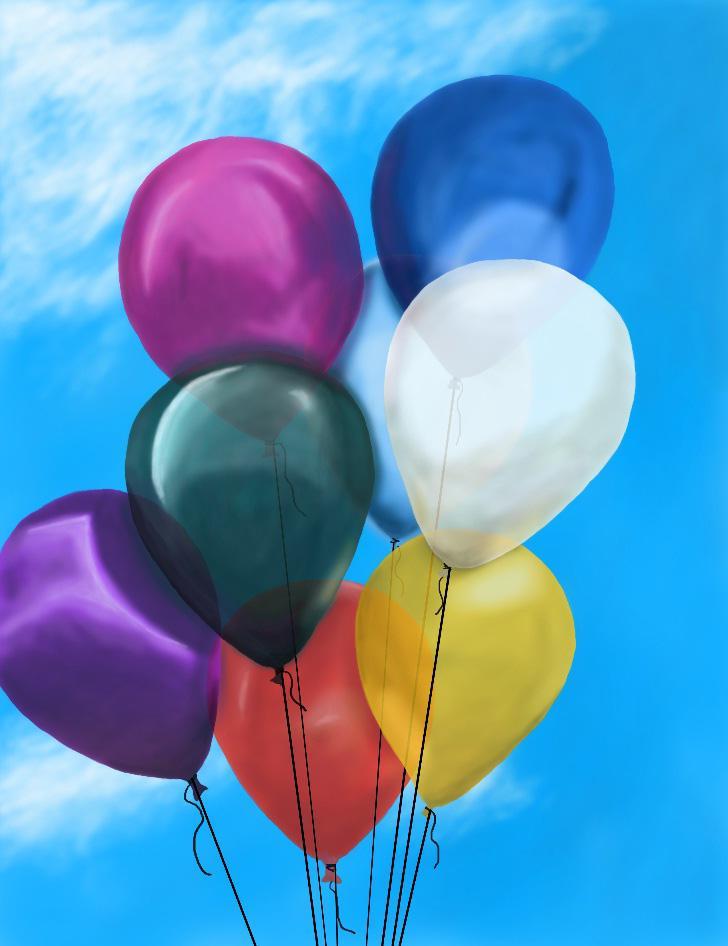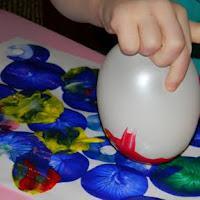The first image is the image on the left, the second image is the image on the right. For the images shown, is this caption "The left image contains at least two children." true? Answer yes or no. No. The first image is the image on the left, the second image is the image on the right. Evaluate the accuracy of this statement regarding the images: "There are multiple children's heads visible.". Is it true? Answer yes or no. No. 